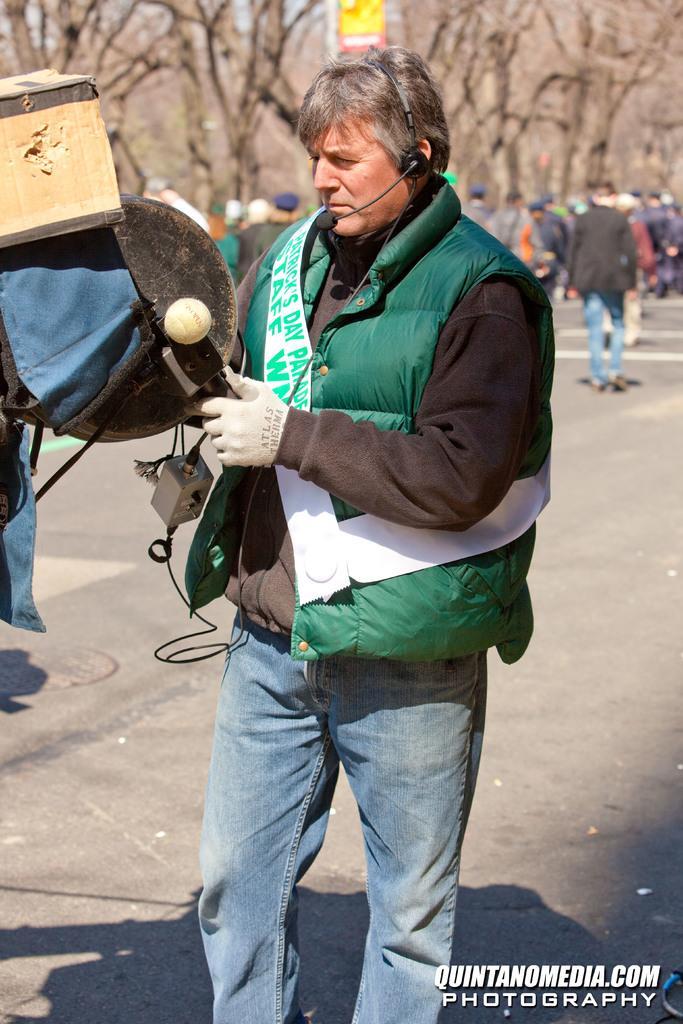In one or two sentences, can you explain what this image depicts? In the center of the image we can see a person is standing and he is wearing a jacket, gloves and headphones with a mike. And we can see he is holding some objects. At the bottom right side of the image, we can see some text. In the background, we can see trees, few people and some objects. 